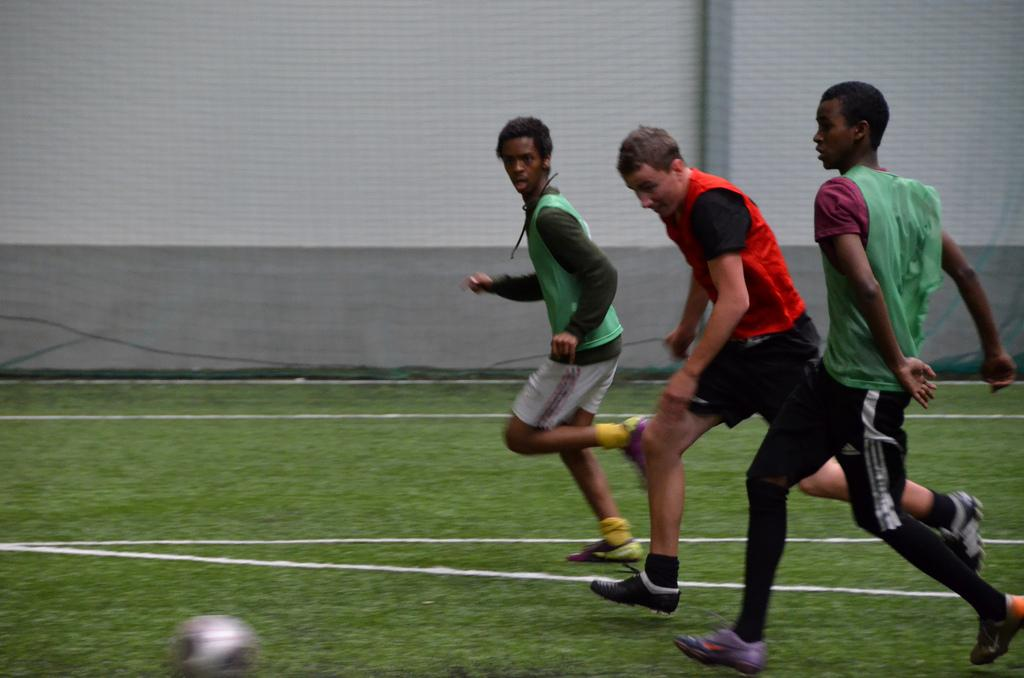How many people are in the image? There are three persons in the image. What are the persons doing in the image? The persons are playing with a ball. What can be seen in the background of the image? There is a sports net in the background of the image. What type of division is being taught by the woman in the image? There is no woman present in the image, and no division is being taught. 